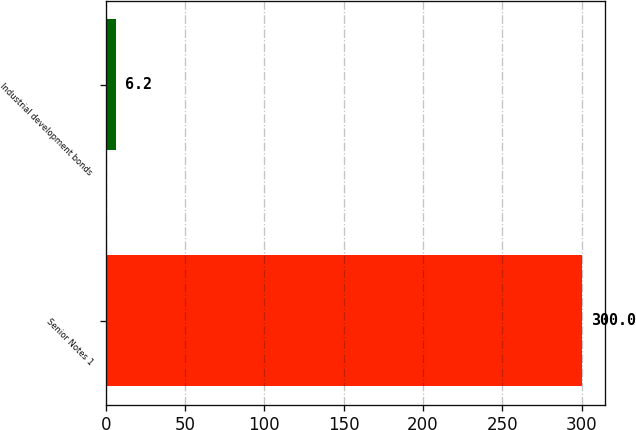Convert chart to OTSL. <chart><loc_0><loc_0><loc_500><loc_500><bar_chart><fcel>Senior Notes 1<fcel>Industrial development bonds<nl><fcel>300<fcel>6.2<nl></chart> 